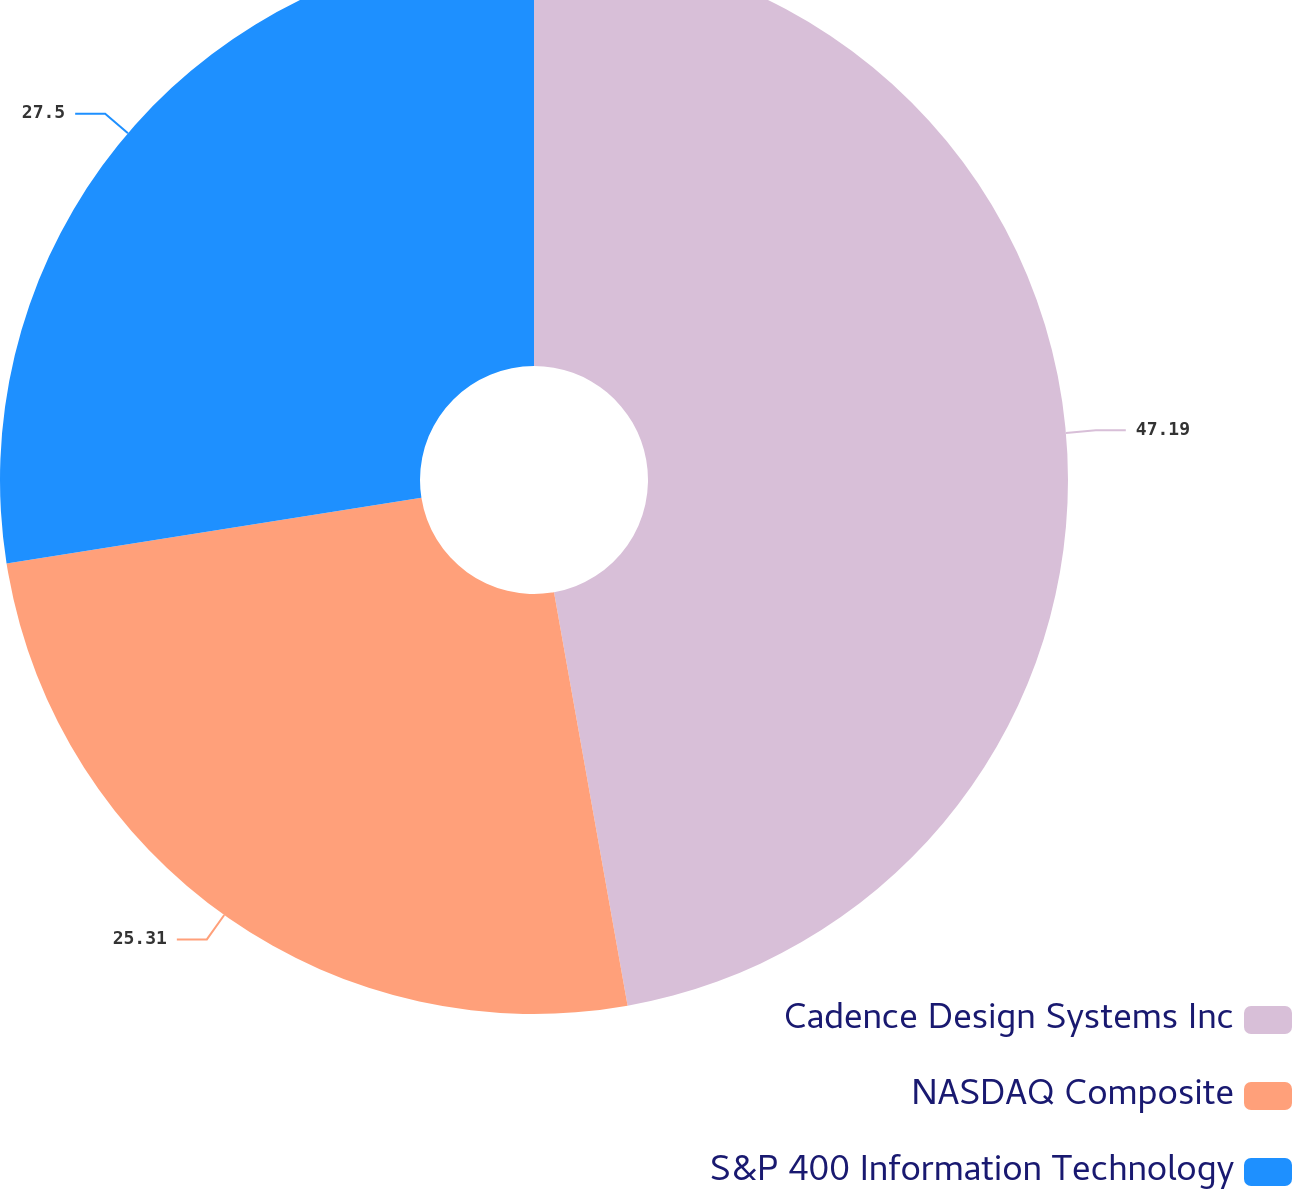Convert chart to OTSL. <chart><loc_0><loc_0><loc_500><loc_500><pie_chart><fcel>Cadence Design Systems Inc<fcel>NASDAQ Composite<fcel>S&P 400 Information Technology<nl><fcel>47.2%<fcel>25.31%<fcel>27.5%<nl></chart> 